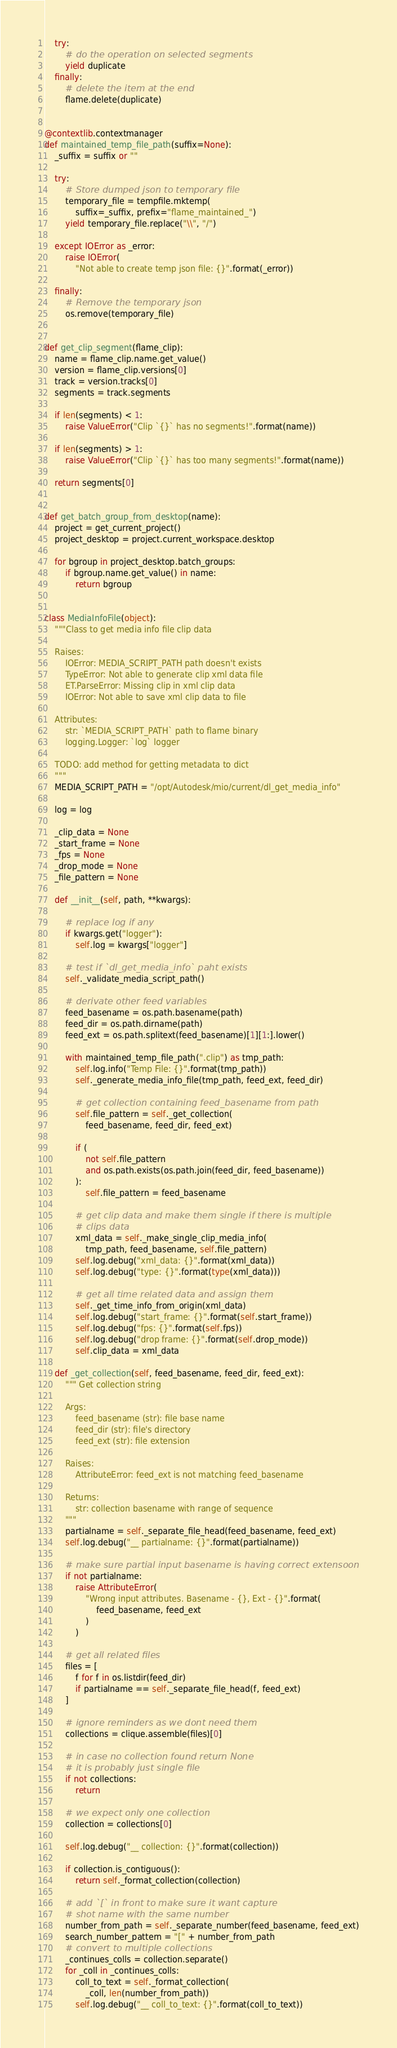<code> <loc_0><loc_0><loc_500><loc_500><_Python_>    try:
        # do the operation on selected segments
        yield duplicate
    finally:
        # delete the item at the end
        flame.delete(duplicate)


@contextlib.contextmanager
def maintained_temp_file_path(suffix=None):
    _suffix = suffix or ""

    try:
        # Store dumped json to temporary file
        temporary_file = tempfile.mktemp(
            suffix=_suffix, prefix="flame_maintained_")
        yield temporary_file.replace("\\", "/")

    except IOError as _error:
        raise IOError(
            "Not able to create temp json file: {}".format(_error))

    finally:
        # Remove the temporary json
        os.remove(temporary_file)


def get_clip_segment(flame_clip):
    name = flame_clip.name.get_value()
    version = flame_clip.versions[0]
    track = version.tracks[0]
    segments = track.segments

    if len(segments) < 1:
        raise ValueError("Clip `{}` has no segments!".format(name))

    if len(segments) > 1:
        raise ValueError("Clip `{}` has too many segments!".format(name))

    return segments[0]


def get_batch_group_from_desktop(name):
    project = get_current_project()
    project_desktop = project.current_workspace.desktop

    for bgroup in project_desktop.batch_groups:
        if bgroup.name.get_value() in name:
            return bgroup


class MediaInfoFile(object):
    """Class to get media info file clip data

    Raises:
        IOError: MEDIA_SCRIPT_PATH path doesn't exists
        TypeError: Not able to generate clip xml data file
        ET.ParseError: Missing clip in xml clip data
        IOError: Not able to save xml clip data to file

    Attributes:
        str: `MEDIA_SCRIPT_PATH` path to flame binary
        logging.Logger: `log` logger

    TODO: add method for getting metadata to dict
    """
    MEDIA_SCRIPT_PATH = "/opt/Autodesk/mio/current/dl_get_media_info"

    log = log

    _clip_data = None
    _start_frame = None
    _fps = None
    _drop_mode = None
    _file_pattern = None

    def __init__(self, path, **kwargs):

        # replace log if any
        if kwargs.get("logger"):
            self.log = kwargs["logger"]

        # test if `dl_get_media_info` paht exists
        self._validate_media_script_path()

        # derivate other feed variables
        feed_basename = os.path.basename(path)
        feed_dir = os.path.dirname(path)
        feed_ext = os.path.splitext(feed_basename)[1][1:].lower()

        with maintained_temp_file_path(".clip") as tmp_path:
            self.log.info("Temp File: {}".format(tmp_path))
            self._generate_media_info_file(tmp_path, feed_ext, feed_dir)

            # get collection containing feed_basename from path
            self.file_pattern = self._get_collection(
                feed_basename, feed_dir, feed_ext)

            if (
                not self.file_pattern
                and os.path.exists(os.path.join(feed_dir, feed_basename))
            ):
                self.file_pattern = feed_basename

            # get clip data and make them single if there is multiple
            # clips data
            xml_data = self._make_single_clip_media_info(
                tmp_path, feed_basename, self.file_pattern)
            self.log.debug("xml_data: {}".format(xml_data))
            self.log.debug("type: {}".format(type(xml_data)))

            # get all time related data and assign them
            self._get_time_info_from_origin(xml_data)
            self.log.debug("start_frame: {}".format(self.start_frame))
            self.log.debug("fps: {}".format(self.fps))
            self.log.debug("drop frame: {}".format(self.drop_mode))
            self.clip_data = xml_data

    def _get_collection(self, feed_basename, feed_dir, feed_ext):
        """ Get collection string

        Args:
            feed_basename (str): file base name
            feed_dir (str): file's directory
            feed_ext (str): file extension

        Raises:
            AttributeError: feed_ext is not matching feed_basename

        Returns:
            str: collection basename with range of sequence
        """
        partialname = self._separate_file_head(feed_basename, feed_ext)
        self.log.debug("__ partialname: {}".format(partialname))

        # make sure partial input basename is having correct extensoon
        if not partialname:
            raise AttributeError(
                "Wrong input attributes. Basename - {}, Ext - {}".format(
                    feed_basename, feed_ext
                )
            )

        # get all related files
        files = [
            f for f in os.listdir(feed_dir)
            if partialname == self._separate_file_head(f, feed_ext)
        ]

        # ignore reminders as we dont need them
        collections = clique.assemble(files)[0]

        # in case no collection found return None
        # it is probably just single file
        if not collections:
            return

        # we expect only one collection
        collection = collections[0]

        self.log.debug("__ collection: {}".format(collection))

        if collection.is_contiguous():
            return self._format_collection(collection)

        # add `[` in front to make sure it want capture
        # shot name with the same number
        number_from_path = self._separate_number(feed_basename, feed_ext)
        search_number_pattern = "[" + number_from_path
        # convert to multiple collections
        _continues_colls = collection.separate()
        for _coll in _continues_colls:
            coll_to_text = self._format_collection(
                _coll, len(number_from_path))
            self.log.debug("__ coll_to_text: {}".format(coll_to_text))</code> 